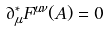Convert formula to latex. <formula><loc_0><loc_0><loc_500><loc_500>\partial _ { \mu } ^ { * } F ^ { \mu \nu } ( A ) = 0</formula> 